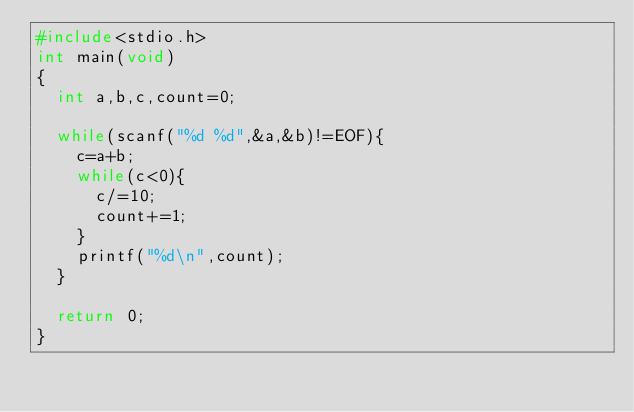<code> <loc_0><loc_0><loc_500><loc_500><_C_>#include<stdio.h>
int main(void)
{
  int a,b,c,count=0;

  while(scanf("%d %d",&a,&b)!=EOF){
    c=a+b;
    while(c<0){
      c/=10;
      count+=1;
    }
    printf("%d\n",count);
  }

  return 0;
}</code> 